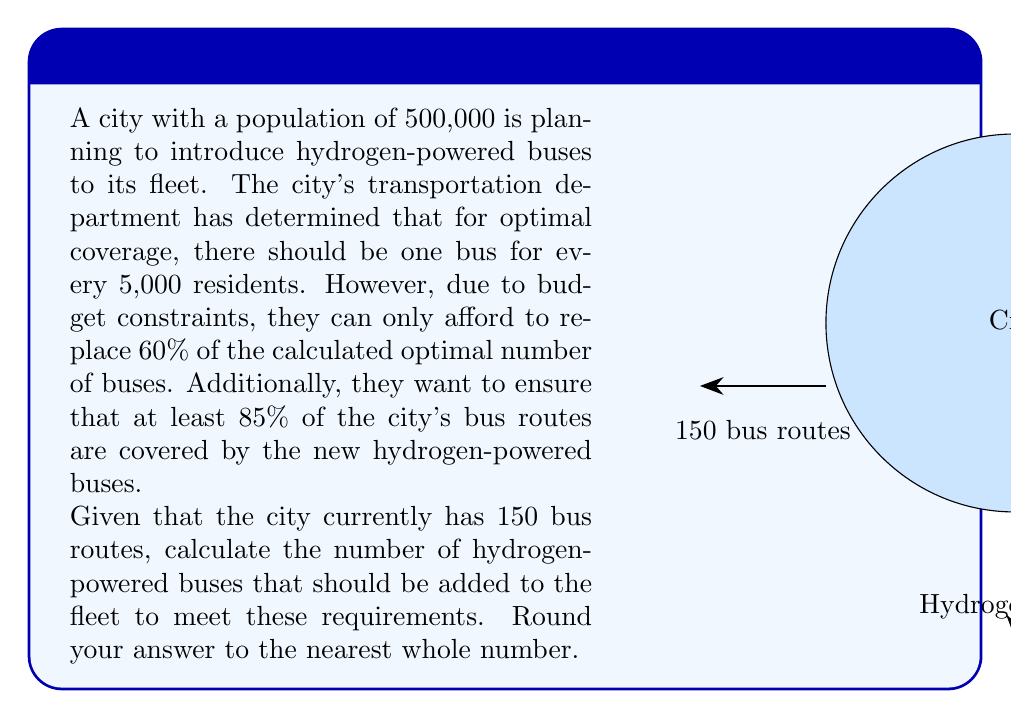Provide a solution to this math problem. Let's approach this problem step-by-step:

1) First, let's calculate the optimal number of buses for the city based on population:
   $$\text{Optimal number} = \frac{\text{Population}}{\text{Residents per bus}} = \frac{500,000}{5,000} = 100$$

2) However, due to budget constraints, they can only afford 60% of this number:
   $$\text{Affordable number} = 100 \times 0.60 = 60$$

3) Now, we need to check if this number of buses can cover at least 85% of the city's bus routes:
   $$\text{Minimum routes to cover} = 150 \times 0.85 = 127.5$$

4) We can calculate the percentage of routes that 60 buses can cover:
   $$\text{Percentage covered} = \frac{60}{150} \times 100\% = 40\%$$

5) This is less than the required 85%, so we need to increase the number of buses.

6) To cover 85% of 150 routes, we need:
   $$\text{Number of buses needed} = 150 \times 0.85 = 127.5$$

7) Rounding up to the nearest whole number:
   $$\text{Final number of buses} = 128$$

Therefore, the city should add 128 hydrogen-powered buses to its fleet to meet the requirements.
Answer: 128 buses 